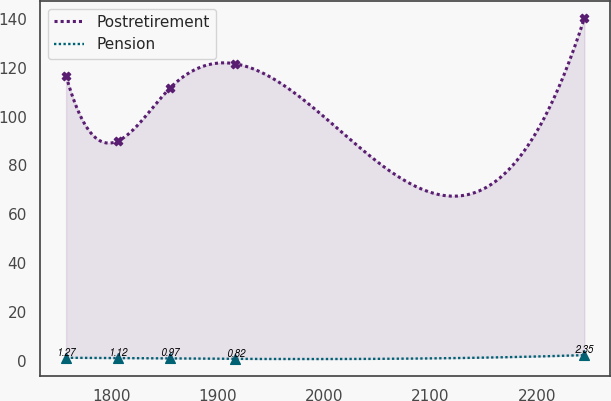Convert chart. <chart><loc_0><loc_0><loc_500><loc_500><line_chart><ecel><fcel>Postretirement<fcel>Pension<nl><fcel>1757.41<fcel>116.61<fcel>1.27<nl><fcel>1806.14<fcel>90.04<fcel>1.12<nl><fcel>1854.87<fcel>111.58<fcel>0.97<nl><fcel>1916.28<fcel>121.64<fcel>0.82<nl><fcel>2244.67<fcel>140.34<fcel>2.35<nl></chart> 